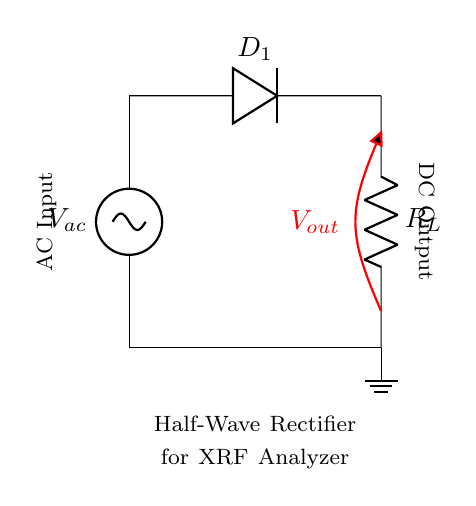What type of rectifier is shown? The circuit diagram depicts a half-wave rectifier, characterized by the presence of one diode that conducts during one half of the AC cycle while blocking during the other half.
Answer: half-wave rectifier What component allows current to flow in one direction? The component that allows current to flow in one direction is the diode (D1), which is specifically designed to allow current to pass through in one direction while preventing it in the opposite direction.
Answer: diode What is the load component in the circuit? The load component in this circuit is the resistor (R_L), which represents the load that receives the converted DC output from the rectifier.
Answer: resistor What type of output voltage is produced? The output voltage produced by this half-wave rectifier is direct current (DC), which is generated as the diode only allows one half of the AC waveform to be utilized.
Answer: DC How many diodes are used in this rectifier? There is one diode used in this half-wave rectifier circuit; this design is typical for half-wave rectifiers, which only require a single diode to function.
Answer: one What does the symbol V_out represent in the circuit? The symbol V_out represents the output voltage of the rectifier which is the voltage across the load resistor (R_L) during the conducting phase of the diode.
Answer: output voltage During which half-cycle does the diode conduct? The diode conducts during the positive half-cycle of the AC input voltage, as it allows current to flow only when the input voltage is above zero, effectively blocking the negative half-cycle.
Answer: positive 